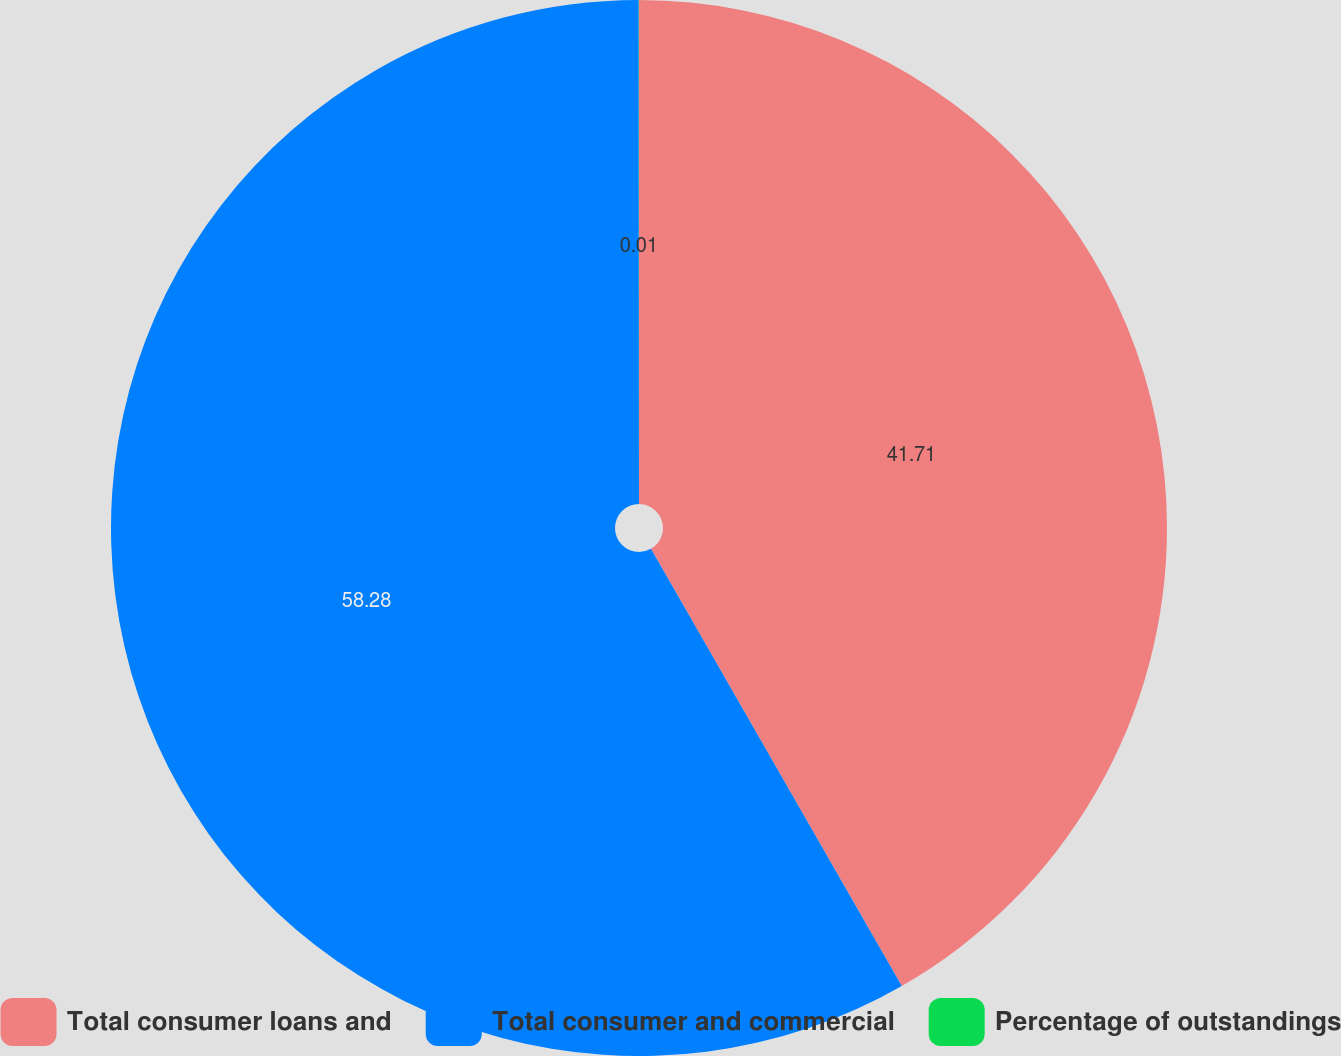Convert chart to OTSL. <chart><loc_0><loc_0><loc_500><loc_500><pie_chart><fcel>Total consumer loans and<fcel>Total consumer and commercial<fcel>Percentage of outstandings<nl><fcel>41.71%<fcel>58.28%<fcel>0.01%<nl></chart> 